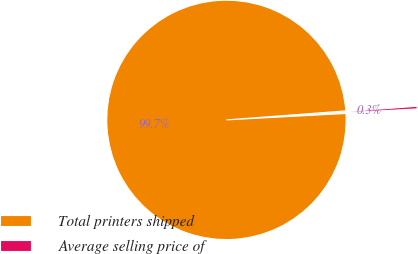Convert chart. <chart><loc_0><loc_0><loc_500><loc_500><pie_chart><fcel>Total printers shipped<fcel>Average selling price of<nl><fcel>99.65%<fcel>0.35%<nl></chart> 